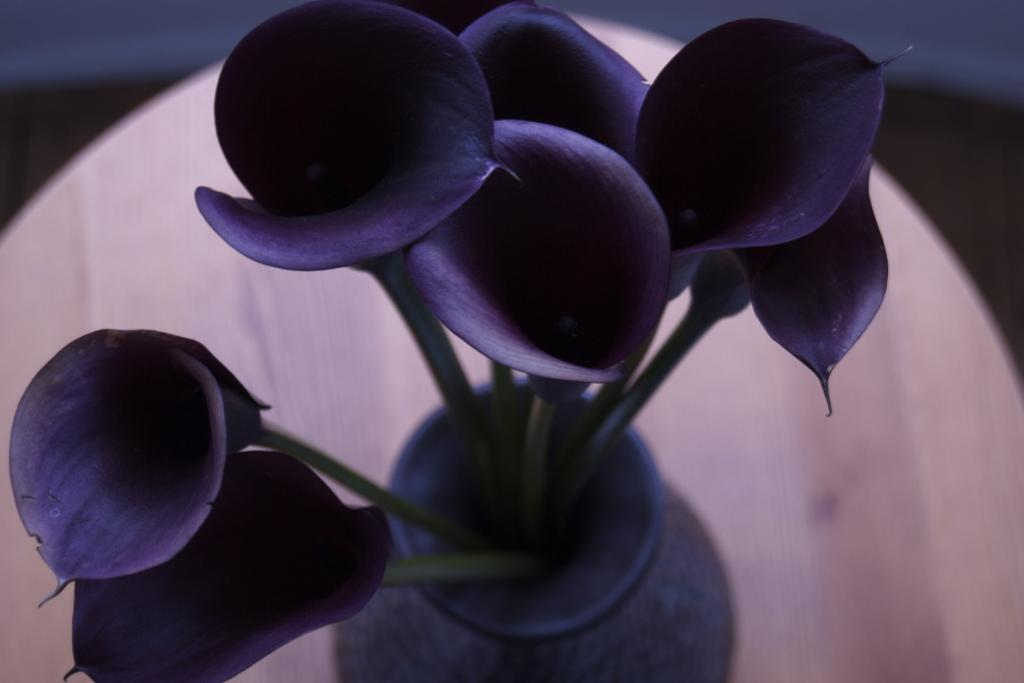What object can be seen in the image? There is a flower vase in the image. Where is the flower vase placed? The flower vase is arranged on a wooden stool. Can you describe the background of the image? The background of the image is blurred. How many people are there are people in the crowd in the image? There is no crowd present in the image; it features a flower vase on a wooden stool with a blurred background. 